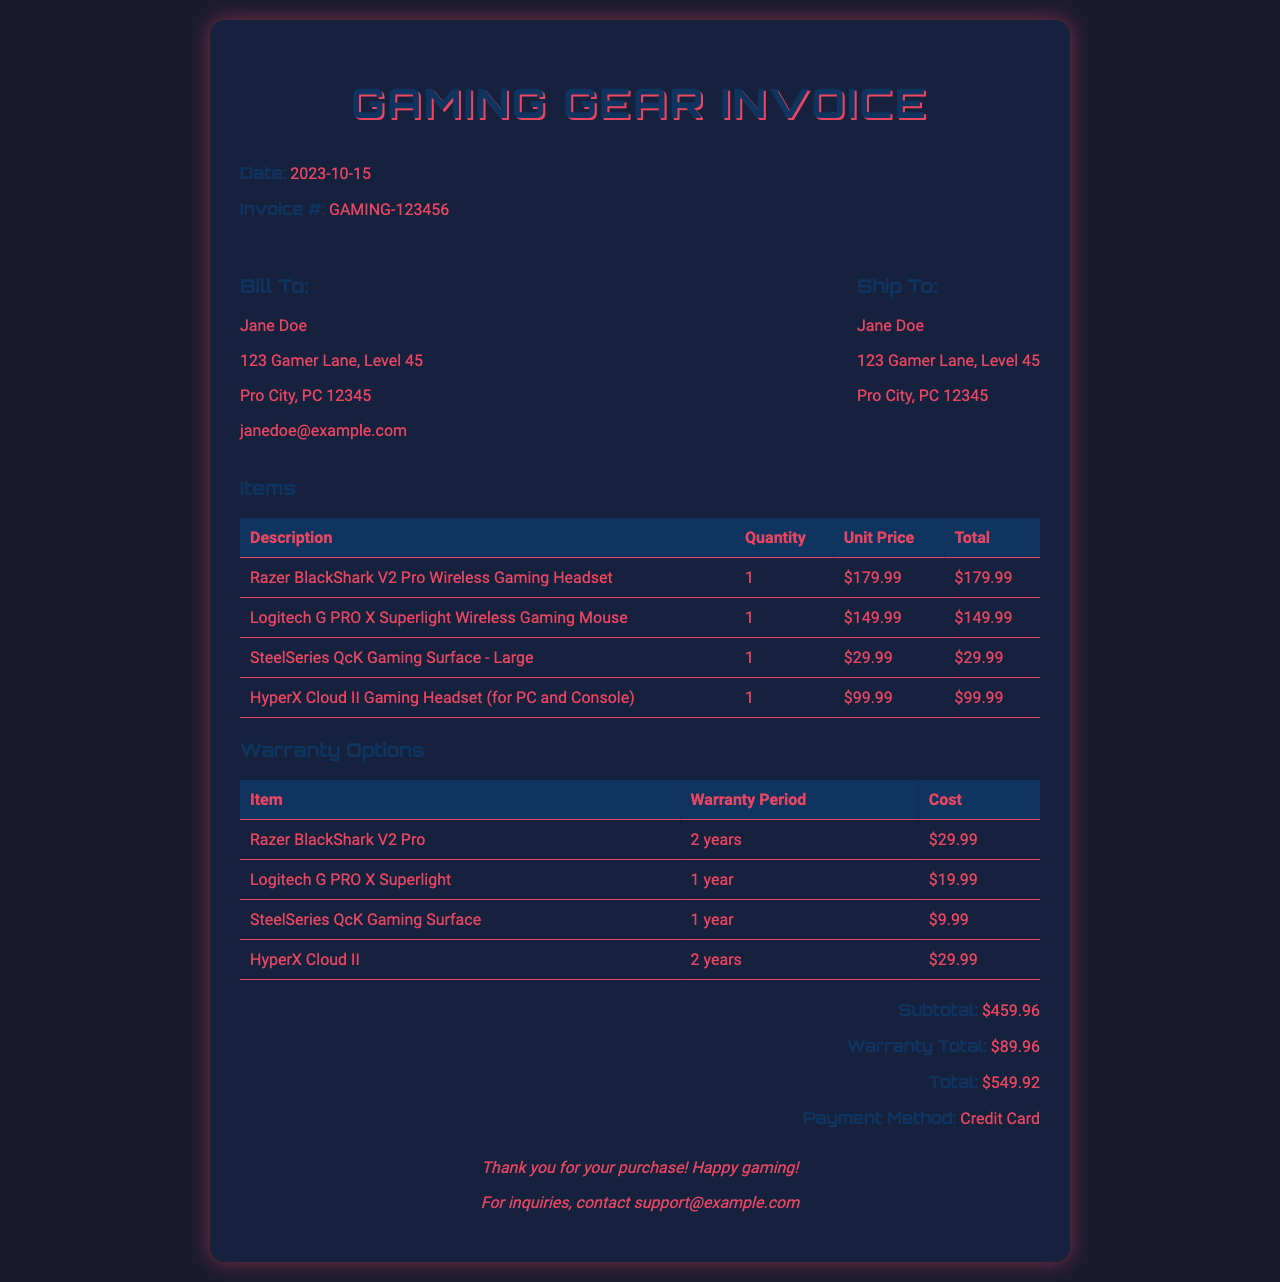What is the invoice number? The invoice number is presented prominently in the document for record-keeping.
Answer: GAMING-123456 What is the date of the invoice? The date indicates when the invoice was issued and is clearly shown in the header section.
Answer: 2023-10-15 Who is the billed person? The 'Bill To' section specifies the individual responsible for payment.
Answer: Jane Doe What is the total cost of the items before warranty? The subtotal represents the total amount for the items purchased, prior to any additional warranty expenses.
Answer: $459.96 How much is the warranty for the Razer BlackShark V2 Pro? The warranty section specifies the cost associated with extending the warranty for particular items.
Answer: $29.99 What is the total warranty cost? The warranty total sums up the costs for all warranties chosen for the items in the purchase.
Answer: $89.96 What is the total amount due for this invoice? The total indicates the final amount that needs to be paid, including items and warranty.
Answer: $549.92 What payment method was used? The document specifies how the payment was processed for transparency and record-keeping.
Answer: Credit Card How long is the warranty for the Logitech G PRO X Superlight? The warranty options detail the duration of warranty coverage for each specific item.
Answer: 1 year What is the address of the billed person? The 'Bill To' section includes full address information for shipping clarification.
Answer: 123 Gamer Lane, Level 45, Pro City, PC 12345 